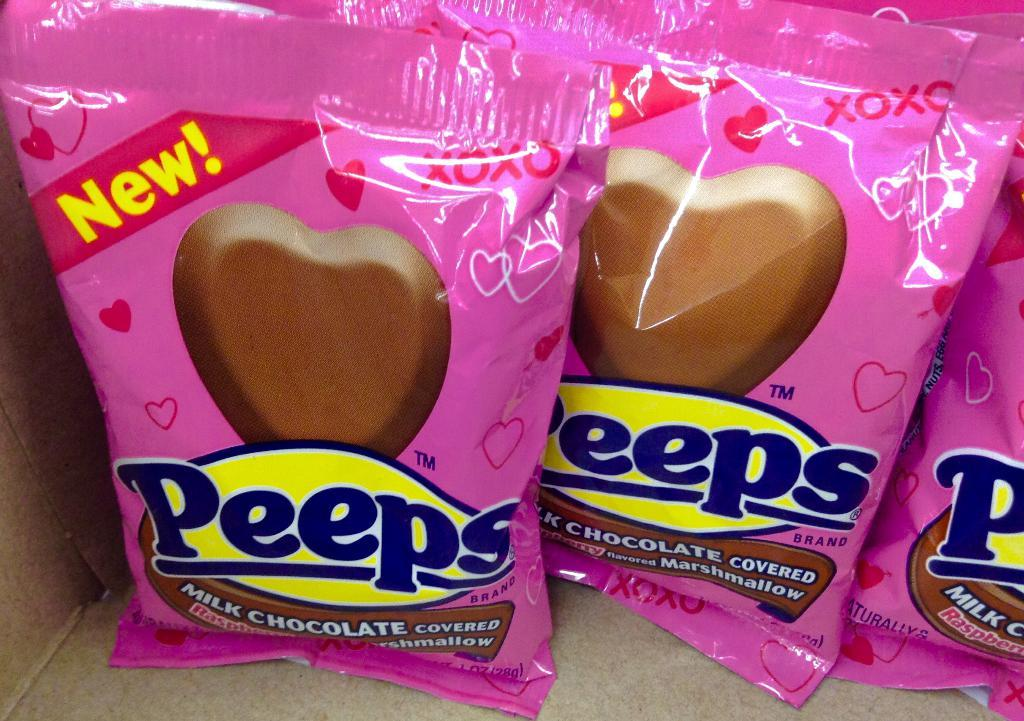What type of confectionery is present in the image? The image contains chocolates. What color are the wrappers of the chocolates? The wrappers of the chocolates are pink. How are the chocolates stored in the image? The chocolates appear to be kept in a box. What hobbies do the cattle in the image enjoy? There are no cattle present in the image, as it features chocolates with pink wrappers stored in a box. 